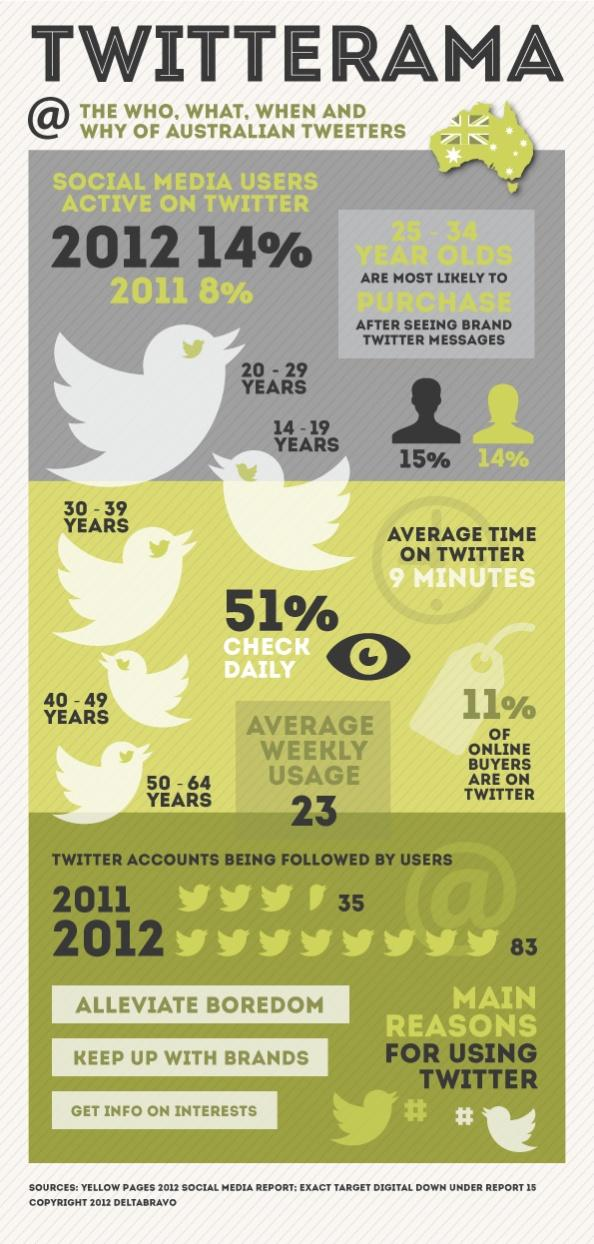Mention a couple of crucial points in this snapshot. In 2011, approximately 8% of social media users in Australia were active on Twitter. As of 2012, it was reported that approximately 15% of Twitter users in Australia were male. In 2012, it was reported that 14% of Twitter users in Australia were female. In 2012, 83 Twitter accounts were followed by users in Australia. As of 2012, the youngest age group of Twitter users in Australia was 14 to 19 years old. 